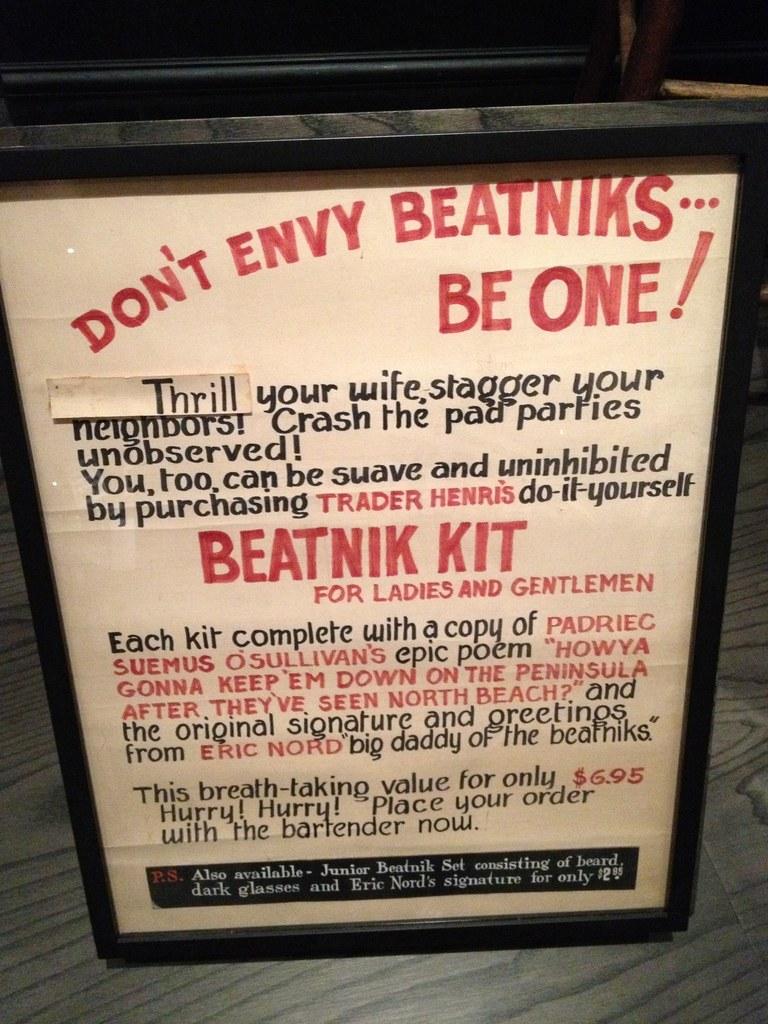What colour is the phrase "beatnik kit"?
Your response must be concise. Red. 